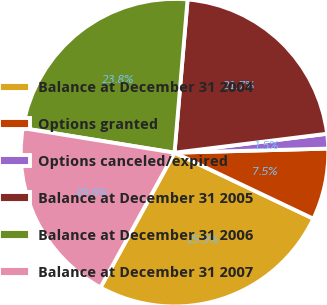<chart> <loc_0><loc_0><loc_500><loc_500><pie_chart><fcel>Balance at December 31 2004<fcel>Options granted<fcel>Options canceled/expired<fcel>Balance at December 31 2005<fcel>Balance at December 31 2006<fcel>Balance at December 31 2007<nl><fcel>25.93%<fcel>7.49%<fcel>1.54%<fcel>21.68%<fcel>23.8%<fcel>19.56%<nl></chart> 